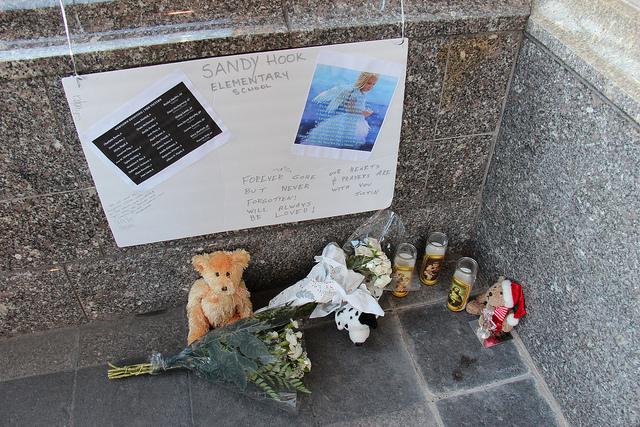What emotions are you feeling by looking at the photo?
Concise answer only. Sadness. Is there a bear in the photo?
Answer briefly. Yes. Has the bear been damaged?
Concise answer only. No. What tragedy is this memorial for?
Keep it brief. Sandy hook. 